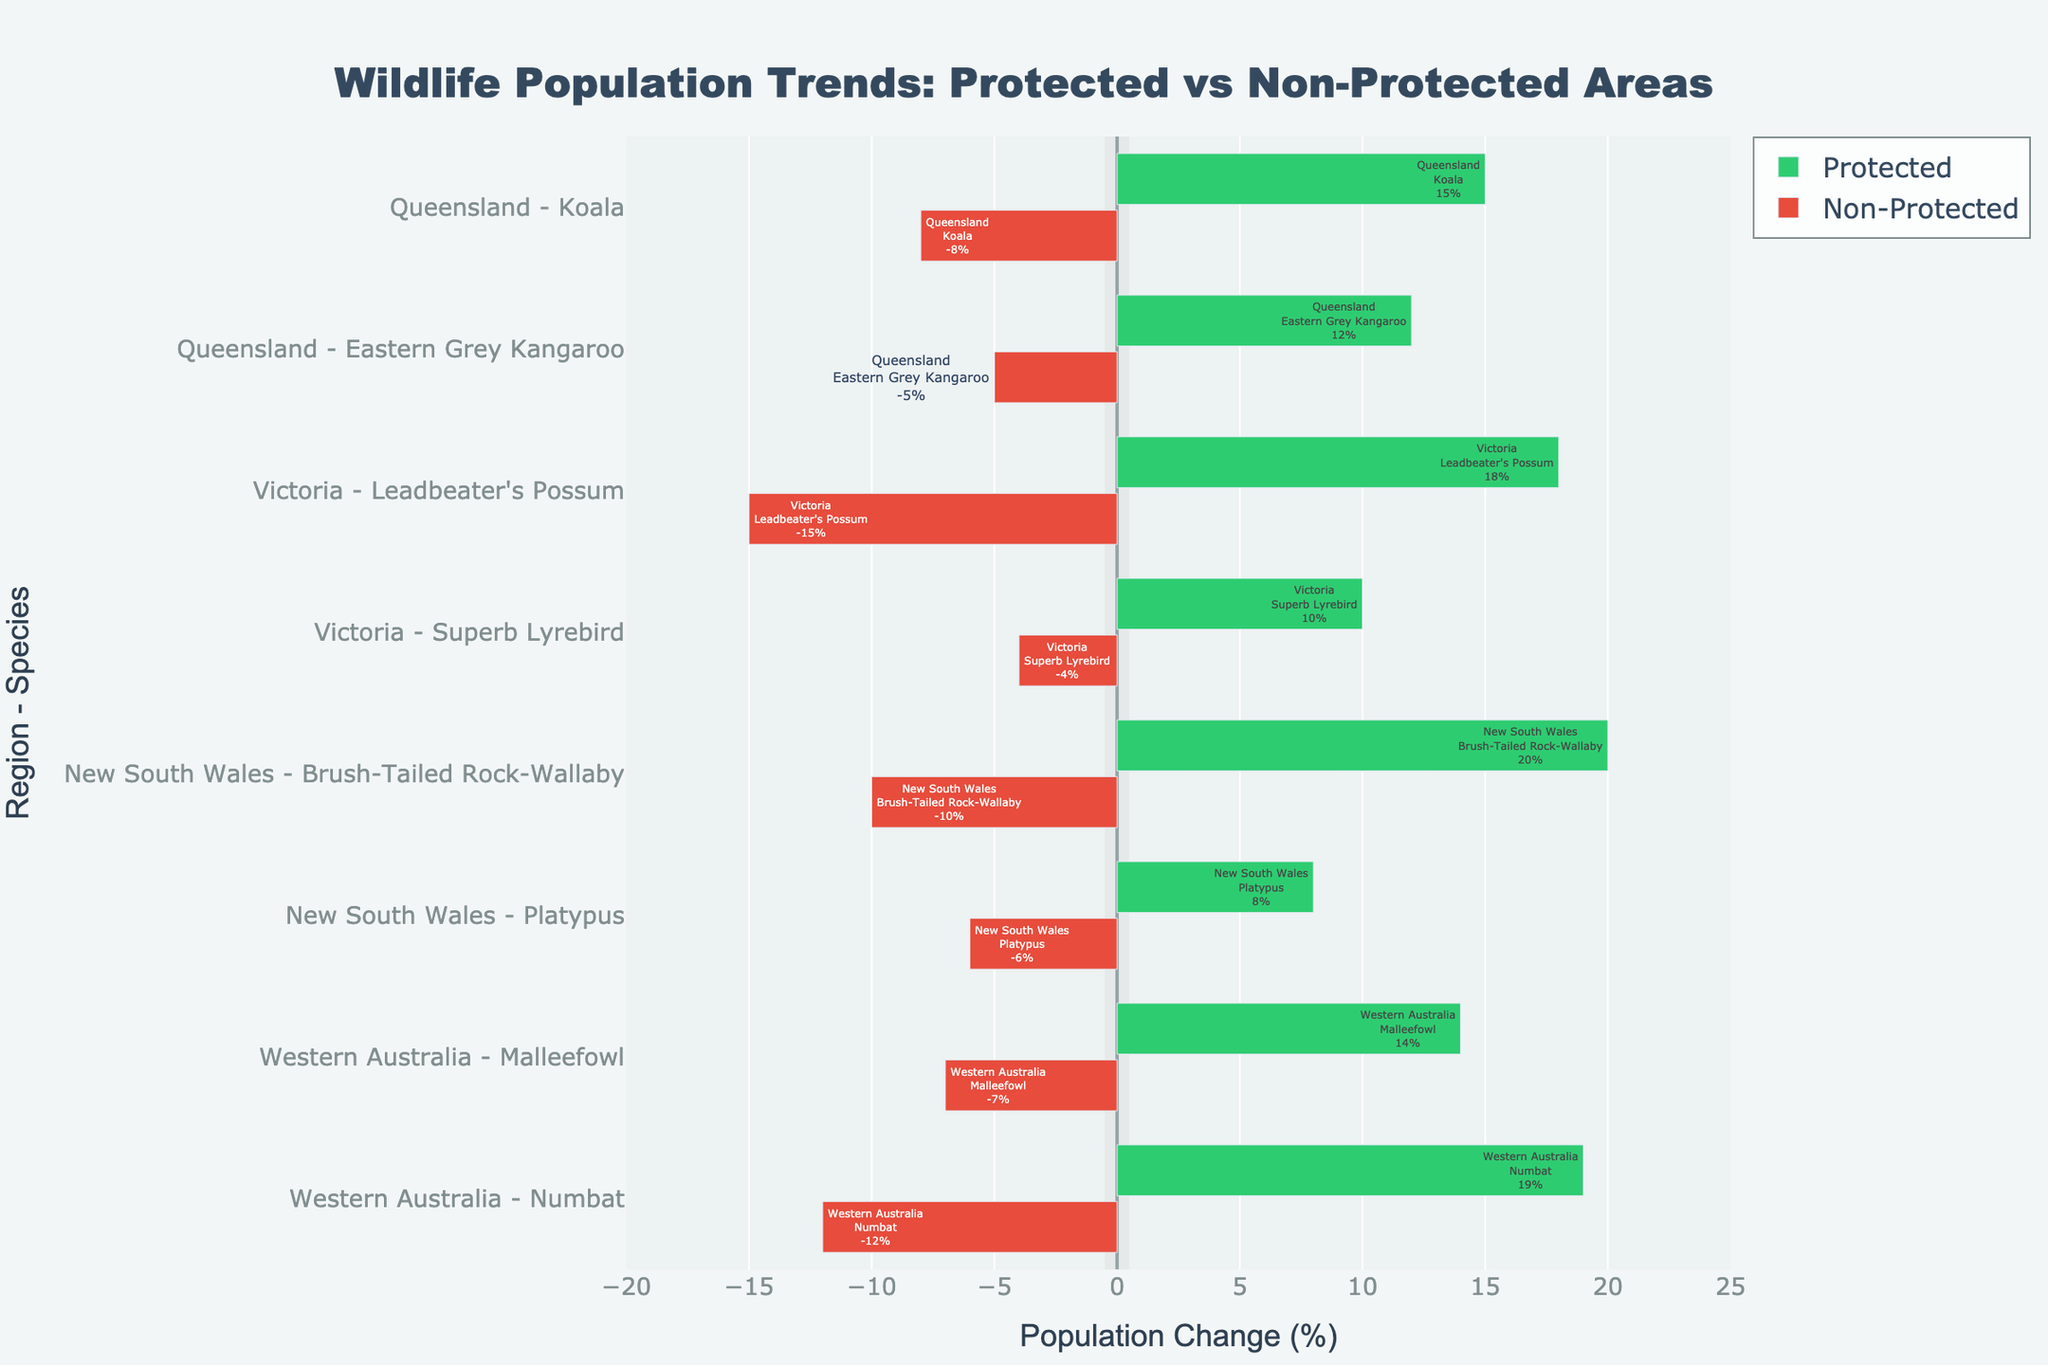Which species in Victoria has the highest positive population change in protected areas? In Victoria, compare the population changes for protected areas. Leadbeater's Possum has an 18% increase, and Superb Lyrebird has a 10% increase. Thus, Leadbeater's Possum has the highest positive population change.
Answer: Leadbeater's Possum What is the total population change for the Eastern Grey Kangaroo in Queensland? Add the population change for protected and non-protected areas in Queensland for Eastern Grey Kangaroo. In protected areas, it is 12%, and in non-protected areas, it is -5%. So, the total is 12% - 5% = 7%.
Answer: 7% Which state has the most significant negative impact on wildlife in non-protected areas? Look for the state with the most significant negative population change in non-protected areas. Leadbeater's Possum in Victoria shows a -15% change, which is the largest negative change compared to other regions.
Answer: Victoria Compare the population change of the Koala in Queensland to the Brush-Tailed Rock-Wallaby in New South Wales. Which species shows a more positive trend in protected areas? Compare the population changes: Koala in Queensland has a 15% increase, while Brush-Tailed Rock-Wallaby in New South Wales shows a 20% increase. The Brush-Tailed Rock-Wallaby shows a more positive trend.
Answer: Brush-Tailed Rock-Wallaby How does the population change of the Numbat in Western Australia compare between protected and non-protected areas? Look at the population changes for Numbat in both areas. Numbat in protected areas has a 19% increase, while in non-protected areas, it shows a -12% change. The protected areas show a significantly positive change compared to the non-protected ones.
Answer: Protected areas Between New South Wales and Western Australia, which state shows a greater average population increase in protected areas? Calculate the average population change in protected areas for both states. For New South Wales: (20% + 8%) / 2 = 14%. For Western Australia: (14% + 19%) / 2 = 16.5%. Western Australia has a greater average increase.
Answer: Western Australia Which region shows the smallest difference in population change between protected and non-protected areas for any species? Calculate the difference in population changes for each species in all regions. The smallest difference is for the Superb Lyrebird in Victoria, with a difference of 10% - (-4%) = 14%.
Answer: Victoria (Superb Lyrebird) In protected areas, which species has the highest population increase across all regions? Compare the population increases of all species in protected areas. The Brush-Tailed Rock-Wallaby in New South Wales shows the highest increase with 20%.
Answer: Brush-Tailed Rock-Wallaby 